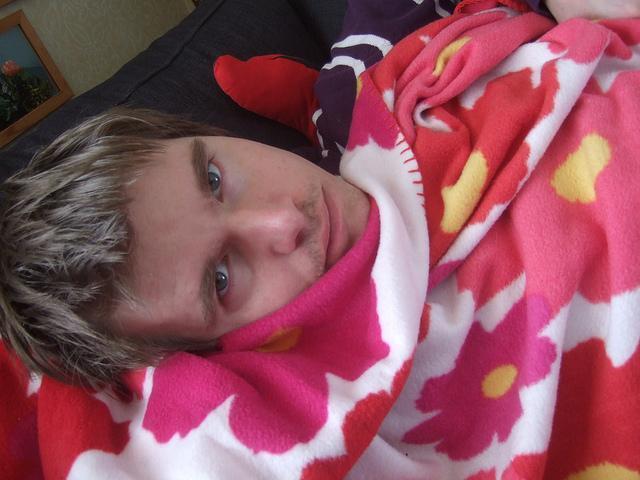How many birds are here?
Give a very brief answer. 0. 